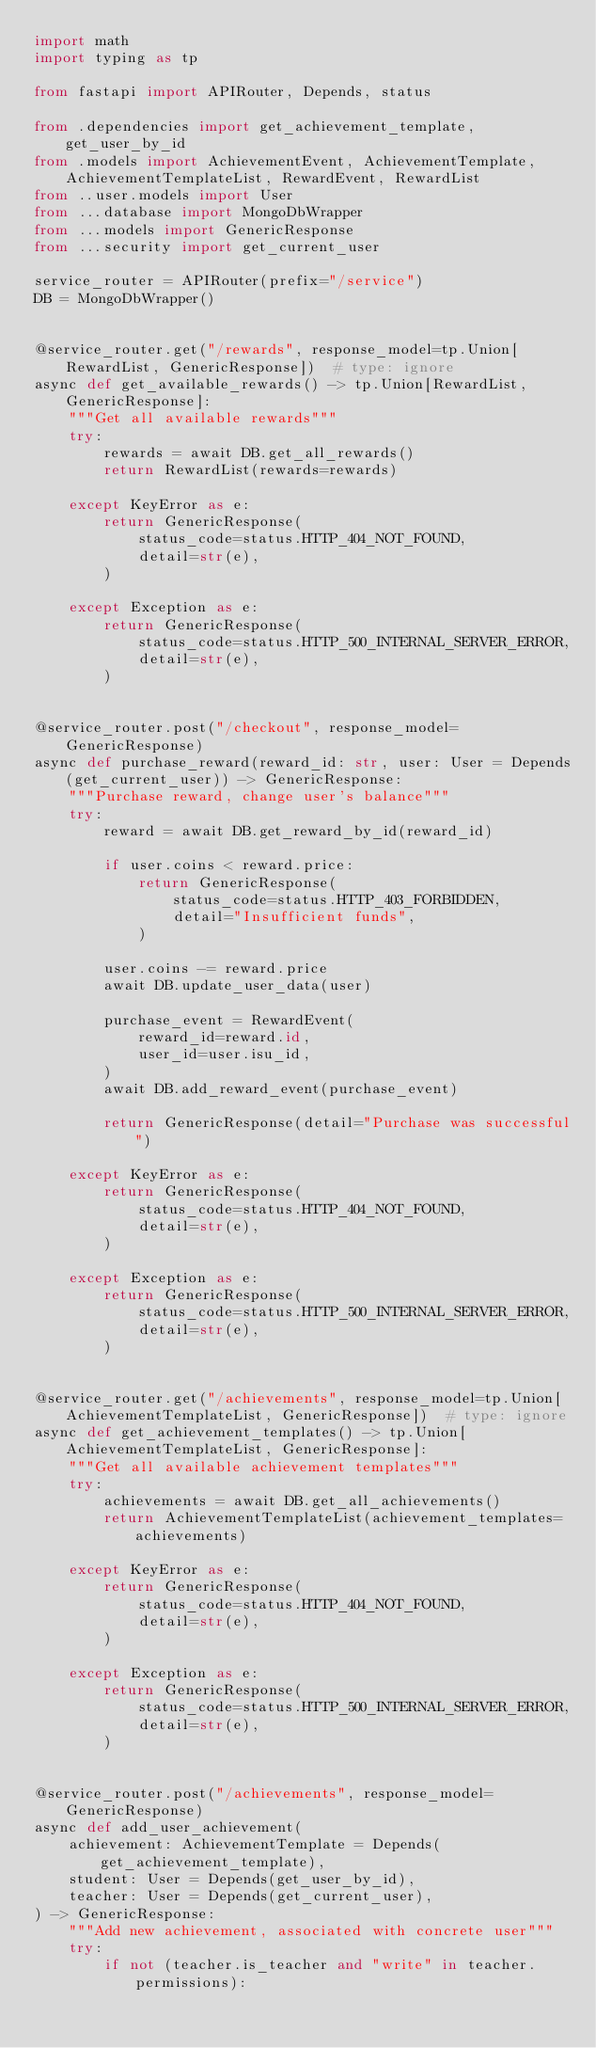<code> <loc_0><loc_0><loc_500><loc_500><_Python_>import math
import typing as tp

from fastapi import APIRouter, Depends, status

from .dependencies import get_achievement_template, get_user_by_id
from .models import AchievementEvent, AchievementTemplate, AchievementTemplateList, RewardEvent, RewardList
from ..user.models import User
from ...database import MongoDbWrapper
from ...models import GenericResponse
from ...security import get_current_user

service_router = APIRouter(prefix="/service")
DB = MongoDbWrapper()


@service_router.get("/rewards", response_model=tp.Union[RewardList, GenericResponse])  # type: ignore
async def get_available_rewards() -> tp.Union[RewardList, GenericResponse]:
    """Get all available rewards"""
    try:
        rewards = await DB.get_all_rewards()
        return RewardList(rewards=rewards)

    except KeyError as e:
        return GenericResponse(
            status_code=status.HTTP_404_NOT_FOUND,
            detail=str(e),
        )

    except Exception as e:
        return GenericResponse(
            status_code=status.HTTP_500_INTERNAL_SERVER_ERROR,
            detail=str(e),
        )


@service_router.post("/checkout", response_model=GenericResponse)
async def purchase_reward(reward_id: str, user: User = Depends(get_current_user)) -> GenericResponse:
    """Purchase reward, change user's balance"""
    try:
        reward = await DB.get_reward_by_id(reward_id)

        if user.coins < reward.price:
            return GenericResponse(
                status_code=status.HTTP_403_FORBIDDEN,
                detail="Insufficient funds",
            )

        user.coins -= reward.price
        await DB.update_user_data(user)

        purchase_event = RewardEvent(
            reward_id=reward.id,
            user_id=user.isu_id,
        )
        await DB.add_reward_event(purchase_event)

        return GenericResponse(detail="Purchase was successful")

    except KeyError as e:
        return GenericResponse(
            status_code=status.HTTP_404_NOT_FOUND,
            detail=str(e),
        )

    except Exception as e:
        return GenericResponse(
            status_code=status.HTTP_500_INTERNAL_SERVER_ERROR,
            detail=str(e),
        )


@service_router.get("/achievements", response_model=tp.Union[AchievementTemplateList, GenericResponse])  # type: ignore
async def get_achievement_templates() -> tp.Union[AchievementTemplateList, GenericResponse]:
    """Get all available achievement templates"""
    try:
        achievements = await DB.get_all_achievements()
        return AchievementTemplateList(achievement_templates=achievements)

    except KeyError as e:
        return GenericResponse(
            status_code=status.HTTP_404_NOT_FOUND,
            detail=str(e),
        )

    except Exception as e:
        return GenericResponse(
            status_code=status.HTTP_500_INTERNAL_SERVER_ERROR,
            detail=str(e),
        )


@service_router.post("/achievements", response_model=GenericResponse)
async def add_user_achievement(
    achievement: AchievementTemplate = Depends(get_achievement_template),
    student: User = Depends(get_user_by_id),
    teacher: User = Depends(get_current_user),
) -> GenericResponse:
    """Add new achievement, associated with concrete user"""
    try:
        if not (teacher.is_teacher and "write" in teacher.permissions):</code> 